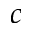<formula> <loc_0><loc_0><loc_500><loc_500>c</formula> 